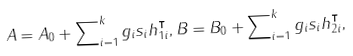<formula> <loc_0><loc_0><loc_500><loc_500>A = A _ { 0 } + \sum \nolimits _ { i = 1 } ^ { k } g _ { i } s _ { i } h _ { 1 i } ^ { \intercal } , B = B _ { 0 } + \sum \nolimits _ { i = 1 } ^ { k } g _ { i } s _ { i } h ^ { \intercal } _ { 2 i } ,</formula> 